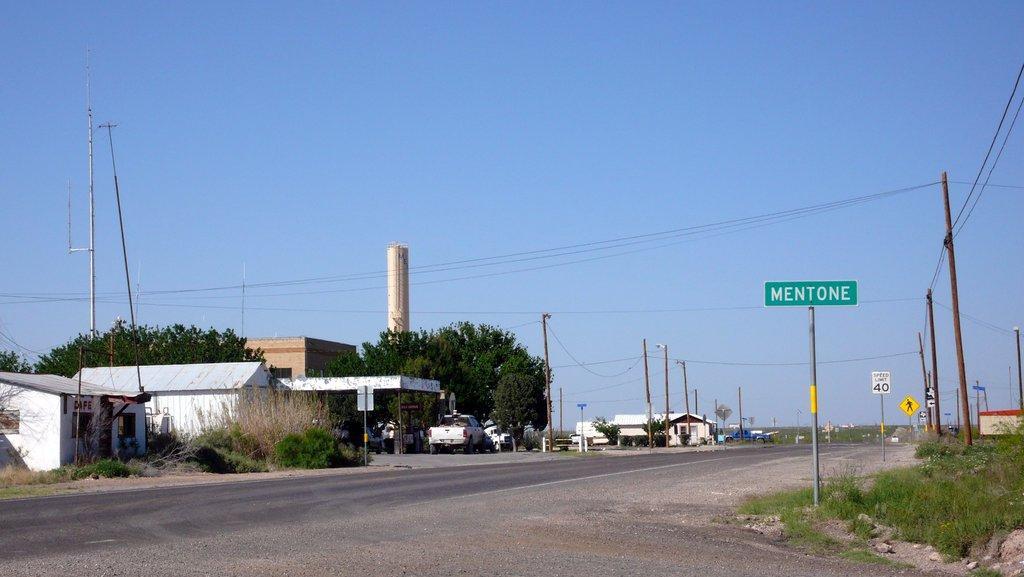Please provide a concise description of this image. In this image there is the sky, there are poles, there are wires, there are trees, there are plants, there are vehicles, there are houses towards the left of the image, there are boards, there is grass towards the right of the image, there is a road. 